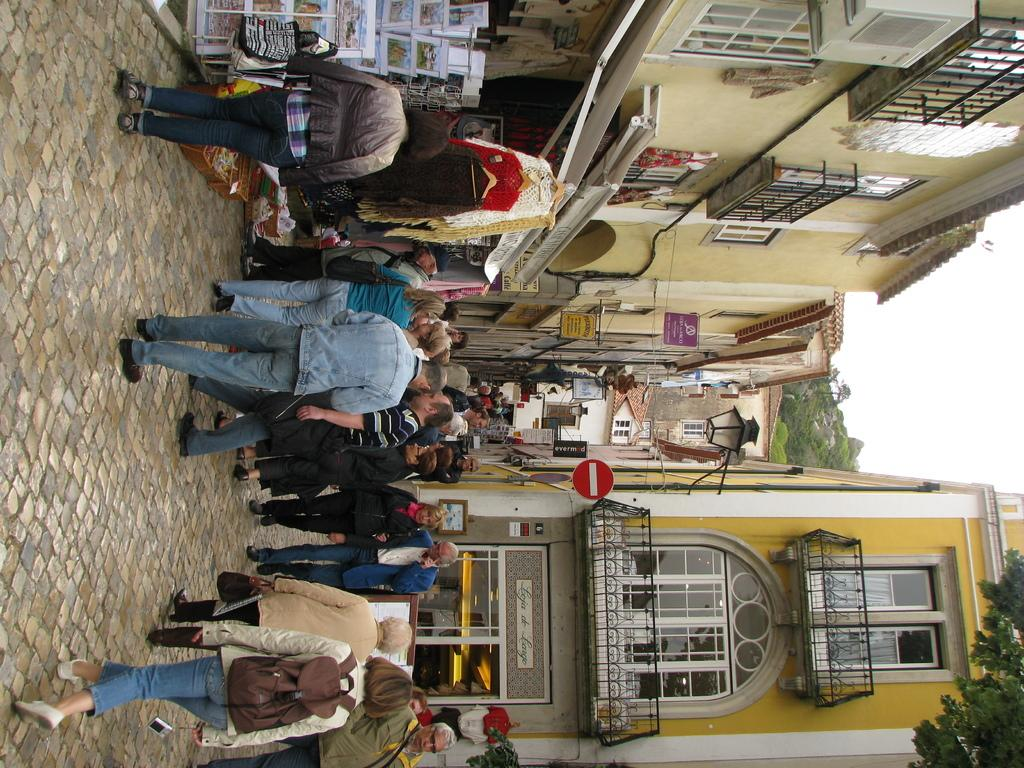What are the people in the image doing? The people in the image are walking. On what surface are the people walking? The people are walking on a path. What can be seen on either side of the path? There are buildings on either side of the path. What type of feeling can be seen on the faces of the birds in the image? There are no birds present in the image, so it is not possible to determine their feelings. 